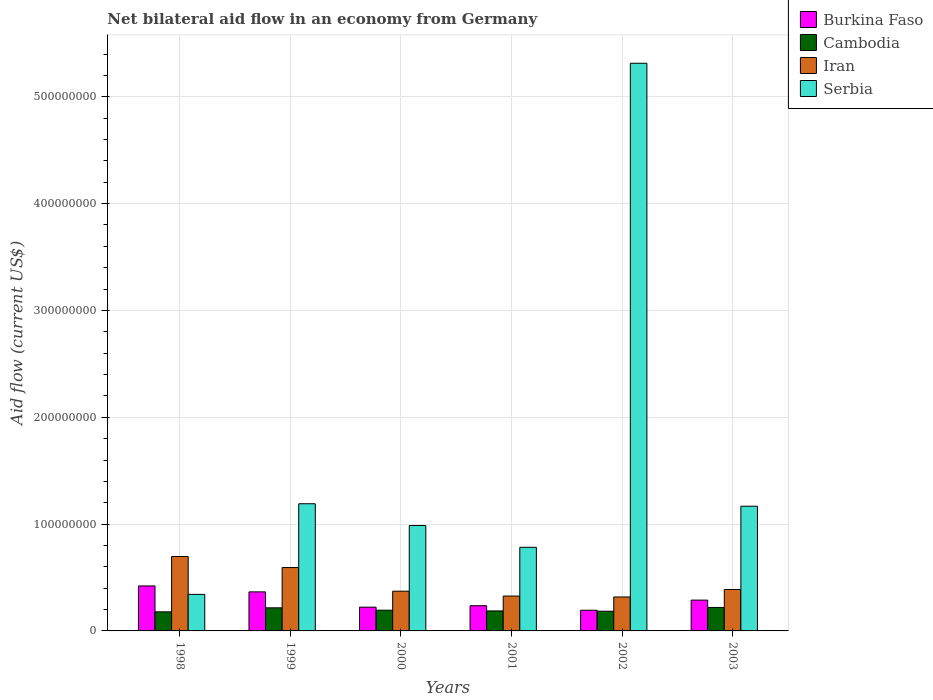Are the number of bars on each tick of the X-axis equal?
Make the answer very short. Yes. How many bars are there on the 2nd tick from the right?
Offer a terse response. 4. What is the label of the 5th group of bars from the left?
Ensure brevity in your answer.  2002. In how many cases, is the number of bars for a given year not equal to the number of legend labels?
Provide a succinct answer. 0. What is the net bilateral aid flow in Iran in 2000?
Offer a very short reply. 3.72e+07. Across all years, what is the maximum net bilateral aid flow in Serbia?
Offer a terse response. 5.31e+08. Across all years, what is the minimum net bilateral aid flow in Serbia?
Provide a succinct answer. 3.42e+07. In which year was the net bilateral aid flow in Burkina Faso maximum?
Keep it short and to the point. 1998. In which year was the net bilateral aid flow in Iran minimum?
Your answer should be very brief. 2002. What is the total net bilateral aid flow in Cambodia in the graph?
Offer a very short reply. 1.18e+08. What is the difference between the net bilateral aid flow in Burkina Faso in 1998 and that in 1999?
Provide a short and direct response. 5.57e+06. What is the difference between the net bilateral aid flow in Serbia in 2000 and the net bilateral aid flow in Cambodia in 1998?
Keep it short and to the point. 8.08e+07. What is the average net bilateral aid flow in Burkina Faso per year?
Give a very brief answer. 2.88e+07. In the year 1999, what is the difference between the net bilateral aid flow in Serbia and net bilateral aid flow in Burkina Faso?
Your answer should be very brief. 8.25e+07. What is the ratio of the net bilateral aid flow in Cambodia in 1998 to that in 2002?
Give a very brief answer. 0.97. Is the difference between the net bilateral aid flow in Serbia in 1999 and 2001 greater than the difference between the net bilateral aid flow in Burkina Faso in 1999 and 2001?
Ensure brevity in your answer.  Yes. What is the difference between the highest and the second highest net bilateral aid flow in Burkina Faso?
Ensure brevity in your answer.  5.57e+06. What is the difference between the highest and the lowest net bilateral aid flow in Burkina Faso?
Keep it short and to the point. 2.28e+07. Is it the case that in every year, the sum of the net bilateral aid flow in Burkina Faso and net bilateral aid flow in Cambodia is greater than the sum of net bilateral aid flow in Serbia and net bilateral aid flow in Iran?
Ensure brevity in your answer.  No. What does the 4th bar from the left in 2001 represents?
Ensure brevity in your answer.  Serbia. What does the 3rd bar from the right in 1998 represents?
Give a very brief answer. Cambodia. Is it the case that in every year, the sum of the net bilateral aid flow in Cambodia and net bilateral aid flow in Serbia is greater than the net bilateral aid flow in Iran?
Your response must be concise. No. How many bars are there?
Give a very brief answer. 24. Are all the bars in the graph horizontal?
Provide a succinct answer. No. How many years are there in the graph?
Offer a terse response. 6. Does the graph contain grids?
Keep it short and to the point. Yes. Where does the legend appear in the graph?
Ensure brevity in your answer.  Top right. What is the title of the graph?
Ensure brevity in your answer.  Net bilateral aid flow in an economy from Germany. Does "St. Martin (French part)" appear as one of the legend labels in the graph?
Your answer should be very brief. No. What is the label or title of the X-axis?
Your answer should be very brief. Years. What is the label or title of the Y-axis?
Give a very brief answer. Aid flow (current US$). What is the Aid flow (current US$) of Burkina Faso in 1998?
Provide a succinct answer. 4.21e+07. What is the Aid flow (current US$) of Cambodia in 1998?
Keep it short and to the point. 1.78e+07. What is the Aid flow (current US$) in Iran in 1998?
Offer a very short reply. 6.97e+07. What is the Aid flow (current US$) in Serbia in 1998?
Provide a short and direct response. 3.42e+07. What is the Aid flow (current US$) of Burkina Faso in 1999?
Provide a short and direct response. 3.65e+07. What is the Aid flow (current US$) in Cambodia in 1999?
Provide a short and direct response. 2.16e+07. What is the Aid flow (current US$) of Iran in 1999?
Keep it short and to the point. 5.93e+07. What is the Aid flow (current US$) of Serbia in 1999?
Your response must be concise. 1.19e+08. What is the Aid flow (current US$) of Burkina Faso in 2000?
Ensure brevity in your answer.  2.22e+07. What is the Aid flow (current US$) in Cambodia in 2000?
Your answer should be compact. 1.94e+07. What is the Aid flow (current US$) in Iran in 2000?
Give a very brief answer. 3.72e+07. What is the Aid flow (current US$) in Serbia in 2000?
Make the answer very short. 9.86e+07. What is the Aid flow (current US$) in Burkina Faso in 2001?
Make the answer very short. 2.36e+07. What is the Aid flow (current US$) in Cambodia in 2001?
Keep it short and to the point. 1.87e+07. What is the Aid flow (current US$) of Iran in 2001?
Keep it short and to the point. 3.26e+07. What is the Aid flow (current US$) in Serbia in 2001?
Offer a very short reply. 7.83e+07. What is the Aid flow (current US$) of Burkina Faso in 2002?
Give a very brief answer. 1.94e+07. What is the Aid flow (current US$) in Cambodia in 2002?
Your answer should be very brief. 1.84e+07. What is the Aid flow (current US$) in Iran in 2002?
Provide a short and direct response. 3.18e+07. What is the Aid flow (current US$) in Serbia in 2002?
Keep it short and to the point. 5.31e+08. What is the Aid flow (current US$) of Burkina Faso in 2003?
Your answer should be compact. 2.88e+07. What is the Aid flow (current US$) of Cambodia in 2003?
Offer a very short reply. 2.20e+07. What is the Aid flow (current US$) in Iran in 2003?
Offer a terse response. 3.88e+07. What is the Aid flow (current US$) of Serbia in 2003?
Your answer should be very brief. 1.17e+08. Across all years, what is the maximum Aid flow (current US$) of Burkina Faso?
Ensure brevity in your answer.  4.21e+07. Across all years, what is the maximum Aid flow (current US$) in Cambodia?
Your answer should be compact. 2.20e+07. Across all years, what is the maximum Aid flow (current US$) of Iran?
Provide a succinct answer. 6.97e+07. Across all years, what is the maximum Aid flow (current US$) in Serbia?
Your answer should be very brief. 5.31e+08. Across all years, what is the minimum Aid flow (current US$) of Burkina Faso?
Give a very brief answer. 1.94e+07. Across all years, what is the minimum Aid flow (current US$) in Cambodia?
Offer a very short reply. 1.78e+07. Across all years, what is the minimum Aid flow (current US$) in Iran?
Offer a very short reply. 3.18e+07. Across all years, what is the minimum Aid flow (current US$) in Serbia?
Give a very brief answer. 3.42e+07. What is the total Aid flow (current US$) in Burkina Faso in the graph?
Make the answer very short. 1.73e+08. What is the total Aid flow (current US$) of Cambodia in the graph?
Offer a terse response. 1.18e+08. What is the total Aid flow (current US$) in Iran in the graph?
Your response must be concise. 2.69e+08. What is the total Aid flow (current US$) in Serbia in the graph?
Provide a short and direct response. 9.78e+08. What is the difference between the Aid flow (current US$) of Burkina Faso in 1998 and that in 1999?
Your answer should be compact. 5.57e+06. What is the difference between the Aid flow (current US$) of Cambodia in 1998 and that in 1999?
Offer a terse response. -3.77e+06. What is the difference between the Aid flow (current US$) in Iran in 1998 and that in 1999?
Provide a short and direct response. 1.03e+07. What is the difference between the Aid flow (current US$) of Serbia in 1998 and that in 1999?
Offer a terse response. -8.48e+07. What is the difference between the Aid flow (current US$) in Burkina Faso in 1998 and that in 2000?
Provide a short and direct response. 1.99e+07. What is the difference between the Aid flow (current US$) in Cambodia in 1998 and that in 2000?
Offer a terse response. -1.55e+06. What is the difference between the Aid flow (current US$) of Iran in 1998 and that in 2000?
Keep it short and to the point. 3.25e+07. What is the difference between the Aid flow (current US$) of Serbia in 1998 and that in 2000?
Offer a terse response. -6.44e+07. What is the difference between the Aid flow (current US$) of Burkina Faso in 1998 and that in 2001?
Make the answer very short. 1.85e+07. What is the difference between the Aid flow (current US$) of Cambodia in 1998 and that in 2001?
Ensure brevity in your answer.  -8.70e+05. What is the difference between the Aid flow (current US$) of Iran in 1998 and that in 2001?
Your response must be concise. 3.70e+07. What is the difference between the Aid flow (current US$) of Serbia in 1998 and that in 2001?
Keep it short and to the point. -4.41e+07. What is the difference between the Aid flow (current US$) in Burkina Faso in 1998 and that in 2002?
Your answer should be compact. 2.28e+07. What is the difference between the Aid flow (current US$) in Cambodia in 1998 and that in 2002?
Give a very brief answer. -5.90e+05. What is the difference between the Aid flow (current US$) in Iran in 1998 and that in 2002?
Offer a terse response. 3.79e+07. What is the difference between the Aid flow (current US$) of Serbia in 1998 and that in 2002?
Your answer should be compact. -4.97e+08. What is the difference between the Aid flow (current US$) of Burkina Faso in 1998 and that in 2003?
Provide a succinct answer. 1.33e+07. What is the difference between the Aid flow (current US$) in Cambodia in 1998 and that in 2003?
Your answer should be compact. -4.13e+06. What is the difference between the Aid flow (current US$) of Iran in 1998 and that in 2003?
Your answer should be compact. 3.09e+07. What is the difference between the Aid flow (current US$) in Serbia in 1998 and that in 2003?
Provide a succinct answer. -8.26e+07. What is the difference between the Aid flow (current US$) in Burkina Faso in 1999 and that in 2000?
Offer a terse response. 1.43e+07. What is the difference between the Aid flow (current US$) in Cambodia in 1999 and that in 2000?
Your answer should be compact. 2.22e+06. What is the difference between the Aid flow (current US$) in Iran in 1999 and that in 2000?
Make the answer very short. 2.21e+07. What is the difference between the Aid flow (current US$) of Serbia in 1999 and that in 2000?
Keep it short and to the point. 2.04e+07. What is the difference between the Aid flow (current US$) in Burkina Faso in 1999 and that in 2001?
Provide a succinct answer. 1.29e+07. What is the difference between the Aid flow (current US$) in Cambodia in 1999 and that in 2001?
Offer a very short reply. 2.90e+06. What is the difference between the Aid flow (current US$) in Iran in 1999 and that in 2001?
Offer a terse response. 2.67e+07. What is the difference between the Aid flow (current US$) in Serbia in 1999 and that in 2001?
Provide a short and direct response. 4.08e+07. What is the difference between the Aid flow (current US$) in Burkina Faso in 1999 and that in 2002?
Your answer should be compact. 1.72e+07. What is the difference between the Aid flow (current US$) of Cambodia in 1999 and that in 2002?
Your answer should be compact. 3.18e+06. What is the difference between the Aid flow (current US$) of Iran in 1999 and that in 2002?
Your answer should be compact. 2.76e+07. What is the difference between the Aid flow (current US$) in Serbia in 1999 and that in 2002?
Ensure brevity in your answer.  -4.12e+08. What is the difference between the Aid flow (current US$) in Burkina Faso in 1999 and that in 2003?
Offer a terse response. 7.71e+06. What is the difference between the Aid flow (current US$) of Cambodia in 1999 and that in 2003?
Provide a short and direct response. -3.60e+05. What is the difference between the Aid flow (current US$) in Iran in 1999 and that in 2003?
Make the answer very short. 2.06e+07. What is the difference between the Aid flow (current US$) of Serbia in 1999 and that in 2003?
Offer a very short reply. 2.30e+06. What is the difference between the Aid flow (current US$) in Burkina Faso in 2000 and that in 2001?
Your answer should be compact. -1.36e+06. What is the difference between the Aid flow (current US$) of Cambodia in 2000 and that in 2001?
Keep it short and to the point. 6.80e+05. What is the difference between the Aid flow (current US$) of Iran in 2000 and that in 2001?
Your response must be concise. 4.55e+06. What is the difference between the Aid flow (current US$) in Serbia in 2000 and that in 2001?
Give a very brief answer. 2.04e+07. What is the difference between the Aid flow (current US$) of Burkina Faso in 2000 and that in 2002?
Offer a terse response. 2.89e+06. What is the difference between the Aid flow (current US$) of Cambodia in 2000 and that in 2002?
Provide a short and direct response. 9.60e+05. What is the difference between the Aid flow (current US$) in Iran in 2000 and that in 2002?
Ensure brevity in your answer.  5.41e+06. What is the difference between the Aid flow (current US$) in Serbia in 2000 and that in 2002?
Give a very brief answer. -4.33e+08. What is the difference between the Aid flow (current US$) of Burkina Faso in 2000 and that in 2003?
Your response must be concise. -6.59e+06. What is the difference between the Aid flow (current US$) in Cambodia in 2000 and that in 2003?
Offer a very short reply. -2.58e+06. What is the difference between the Aid flow (current US$) in Iran in 2000 and that in 2003?
Your answer should be compact. -1.58e+06. What is the difference between the Aid flow (current US$) of Serbia in 2000 and that in 2003?
Make the answer very short. -1.81e+07. What is the difference between the Aid flow (current US$) of Burkina Faso in 2001 and that in 2002?
Ensure brevity in your answer.  4.25e+06. What is the difference between the Aid flow (current US$) of Iran in 2001 and that in 2002?
Offer a very short reply. 8.60e+05. What is the difference between the Aid flow (current US$) in Serbia in 2001 and that in 2002?
Offer a very short reply. -4.53e+08. What is the difference between the Aid flow (current US$) of Burkina Faso in 2001 and that in 2003?
Ensure brevity in your answer.  -5.23e+06. What is the difference between the Aid flow (current US$) in Cambodia in 2001 and that in 2003?
Keep it short and to the point. -3.26e+06. What is the difference between the Aid flow (current US$) in Iran in 2001 and that in 2003?
Make the answer very short. -6.13e+06. What is the difference between the Aid flow (current US$) of Serbia in 2001 and that in 2003?
Make the answer very short. -3.85e+07. What is the difference between the Aid flow (current US$) in Burkina Faso in 2002 and that in 2003?
Your response must be concise. -9.48e+06. What is the difference between the Aid flow (current US$) of Cambodia in 2002 and that in 2003?
Ensure brevity in your answer.  -3.54e+06. What is the difference between the Aid flow (current US$) of Iran in 2002 and that in 2003?
Ensure brevity in your answer.  -6.99e+06. What is the difference between the Aid flow (current US$) in Serbia in 2002 and that in 2003?
Your answer should be very brief. 4.15e+08. What is the difference between the Aid flow (current US$) in Burkina Faso in 1998 and the Aid flow (current US$) in Cambodia in 1999?
Offer a very short reply. 2.05e+07. What is the difference between the Aid flow (current US$) of Burkina Faso in 1998 and the Aid flow (current US$) of Iran in 1999?
Your response must be concise. -1.72e+07. What is the difference between the Aid flow (current US$) in Burkina Faso in 1998 and the Aid flow (current US$) in Serbia in 1999?
Provide a short and direct response. -7.69e+07. What is the difference between the Aid flow (current US$) in Cambodia in 1998 and the Aid flow (current US$) in Iran in 1999?
Make the answer very short. -4.15e+07. What is the difference between the Aid flow (current US$) in Cambodia in 1998 and the Aid flow (current US$) in Serbia in 1999?
Provide a succinct answer. -1.01e+08. What is the difference between the Aid flow (current US$) of Iran in 1998 and the Aid flow (current US$) of Serbia in 1999?
Your response must be concise. -4.94e+07. What is the difference between the Aid flow (current US$) of Burkina Faso in 1998 and the Aid flow (current US$) of Cambodia in 2000?
Ensure brevity in your answer.  2.27e+07. What is the difference between the Aid flow (current US$) in Burkina Faso in 1998 and the Aid flow (current US$) in Iran in 2000?
Offer a very short reply. 4.92e+06. What is the difference between the Aid flow (current US$) in Burkina Faso in 1998 and the Aid flow (current US$) in Serbia in 2000?
Your answer should be compact. -5.65e+07. What is the difference between the Aid flow (current US$) of Cambodia in 1998 and the Aid flow (current US$) of Iran in 2000?
Give a very brief answer. -1.93e+07. What is the difference between the Aid flow (current US$) in Cambodia in 1998 and the Aid flow (current US$) in Serbia in 2000?
Offer a terse response. -8.08e+07. What is the difference between the Aid flow (current US$) of Iran in 1998 and the Aid flow (current US$) of Serbia in 2000?
Your answer should be very brief. -2.90e+07. What is the difference between the Aid flow (current US$) of Burkina Faso in 1998 and the Aid flow (current US$) of Cambodia in 2001?
Keep it short and to the point. 2.34e+07. What is the difference between the Aid flow (current US$) of Burkina Faso in 1998 and the Aid flow (current US$) of Iran in 2001?
Give a very brief answer. 9.47e+06. What is the difference between the Aid flow (current US$) of Burkina Faso in 1998 and the Aid flow (current US$) of Serbia in 2001?
Your response must be concise. -3.62e+07. What is the difference between the Aid flow (current US$) of Cambodia in 1998 and the Aid flow (current US$) of Iran in 2001?
Offer a very short reply. -1.48e+07. What is the difference between the Aid flow (current US$) of Cambodia in 1998 and the Aid flow (current US$) of Serbia in 2001?
Offer a very short reply. -6.04e+07. What is the difference between the Aid flow (current US$) in Iran in 1998 and the Aid flow (current US$) in Serbia in 2001?
Give a very brief answer. -8.61e+06. What is the difference between the Aid flow (current US$) of Burkina Faso in 1998 and the Aid flow (current US$) of Cambodia in 2002?
Your answer should be very brief. 2.37e+07. What is the difference between the Aid flow (current US$) in Burkina Faso in 1998 and the Aid flow (current US$) in Iran in 2002?
Keep it short and to the point. 1.03e+07. What is the difference between the Aid flow (current US$) in Burkina Faso in 1998 and the Aid flow (current US$) in Serbia in 2002?
Keep it short and to the point. -4.89e+08. What is the difference between the Aid flow (current US$) in Cambodia in 1998 and the Aid flow (current US$) in Iran in 2002?
Provide a short and direct response. -1.39e+07. What is the difference between the Aid flow (current US$) of Cambodia in 1998 and the Aid flow (current US$) of Serbia in 2002?
Offer a terse response. -5.14e+08. What is the difference between the Aid flow (current US$) of Iran in 1998 and the Aid flow (current US$) of Serbia in 2002?
Offer a terse response. -4.62e+08. What is the difference between the Aid flow (current US$) in Burkina Faso in 1998 and the Aid flow (current US$) in Cambodia in 2003?
Your answer should be very brief. 2.01e+07. What is the difference between the Aid flow (current US$) in Burkina Faso in 1998 and the Aid flow (current US$) in Iran in 2003?
Provide a short and direct response. 3.34e+06. What is the difference between the Aid flow (current US$) in Burkina Faso in 1998 and the Aid flow (current US$) in Serbia in 2003?
Keep it short and to the point. -7.46e+07. What is the difference between the Aid flow (current US$) of Cambodia in 1998 and the Aid flow (current US$) of Iran in 2003?
Ensure brevity in your answer.  -2.09e+07. What is the difference between the Aid flow (current US$) of Cambodia in 1998 and the Aid flow (current US$) of Serbia in 2003?
Offer a very short reply. -9.89e+07. What is the difference between the Aid flow (current US$) in Iran in 1998 and the Aid flow (current US$) in Serbia in 2003?
Give a very brief answer. -4.71e+07. What is the difference between the Aid flow (current US$) in Burkina Faso in 1999 and the Aid flow (current US$) in Cambodia in 2000?
Offer a very short reply. 1.71e+07. What is the difference between the Aid flow (current US$) of Burkina Faso in 1999 and the Aid flow (current US$) of Iran in 2000?
Your answer should be compact. -6.50e+05. What is the difference between the Aid flow (current US$) in Burkina Faso in 1999 and the Aid flow (current US$) in Serbia in 2000?
Offer a very short reply. -6.21e+07. What is the difference between the Aid flow (current US$) in Cambodia in 1999 and the Aid flow (current US$) in Iran in 2000?
Provide a succinct answer. -1.56e+07. What is the difference between the Aid flow (current US$) of Cambodia in 1999 and the Aid flow (current US$) of Serbia in 2000?
Provide a succinct answer. -7.70e+07. What is the difference between the Aid flow (current US$) of Iran in 1999 and the Aid flow (current US$) of Serbia in 2000?
Keep it short and to the point. -3.93e+07. What is the difference between the Aid flow (current US$) in Burkina Faso in 1999 and the Aid flow (current US$) in Cambodia in 2001?
Your response must be concise. 1.78e+07. What is the difference between the Aid flow (current US$) of Burkina Faso in 1999 and the Aid flow (current US$) of Iran in 2001?
Make the answer very short. 3.90e+06. What is the difference between the Aid flow (current US$) of Burkina Faso in 1999 and the Aid flow (current US$) of Serbia in 2001?
Ensure brevity in your answer.  -4.17e+07. What is the difference between the Aid flow (current US$) in Cambodia in 1999 and the Aid flow (current US$) in Iran in 2001?
Offer a terse response. -1.10e+07. What is the difference between the Aid flow (current US$) in Cambodia in 1999 and the Aid flow (current US$) in Serbia in 2001?
Offer a very short reply. -5.67e+07. What is the difference between the Aid flow (current US$) of Iran in 1999 and the Aid flow (current US$) of Serbia in 2001?
Offer a very short reply. -1.90e+07. What is the difference between the Aid flow (current US$) in Burkina Faso in 1999 and the Aid flow (current US$) in Cambodia in 2002?
Give a very brief answer. 1.81e+07. What is the difference between the Aid flow (current US$) of Burkina Faso in 1999 and the Aid flow (current US$) of Iran in 2002?
Provide a succinct answer. 4.76e+06. What is the difference between the Aid flow (current US$) of Burkina Faso in 1999 and the Aid flow (current US$) of Serbia in 2002?
Keep it short and to the point. -4.95e+08. What is the difference between the Aid flow (current US$) of Cambodia in 1999 and the Aid flow (current US$) of Iran in 2002?
Offer a very short reply. -1.02e+07. What is the difference between the Aid flow (current US$) in Cambodia in 1999 and the Aid flow (current US$) in Serbia in 2002?
Keep it short and to the point. -5.10e+08. What is the difference between the Aid flow (current US$) in Iran in 1999 and the Aid flow (current US$) in Serbia in 2002?
Your answer should be very brief. -4.72e+08. What is the difference between the Aid flow (current US$) in Burkina Faso in 1999 and the Aid flow (current US$) in Cambodia in 2003?
Offer a terse response. 1.46e+07. What is the difference between the Aid flow (current US$) of Burkina Faso in 1999 and the Aid flow (current US$) of Iran in 2003?
Offer a very short reply. -2.23e+06. What is the difference between the Aid flow (current US$) in Burkina Faso in 1999 and the Aid flow (current US$) in Serbia in 2003?
Provide a succinct answer. -8.02e+07. What is the difference between the Aid flow (current US$) of Cambodia in 1999 and the Aid flow (current US$) of Iran in 2003?
Provide a succinct answer. -1.72e+07. What is the difference between the Aid flow (current US$) of Cambodia in 1999 and the Aid flow (current US$) of Serbia in 2003?
Keep it short and to the point. -9.51e+07. What is the difference between the Aid flow (current US$) of Iran in 1999 and the Aid flow (current US$) of Serbia in 2003?
Your answer should be very brief. -5.74e+07. What is the difference between the Aid flow (current US$) of Burkina Faso in 2000 and the Aid flow (current US$) of Cambodia in 2001?
Offer a very short reply. 3.52e+06. What is the difference between the Aid flow (current US$) of Burkina Faso in 2000 and the Aid flow (current US$) of Iran in 2001?
Keep it short and to the point. -1.04e+07. What is the difference between the Aid flow (current US$) of Burkina Faso in 2000 and the Aid flow (current US$) of Serbia in 2001?
Keep it short and to the point. -5.60e+07. What is the difference between the Aid flow (current US$) of Cambodia in 2000 and the Aid flow (current US$) of Iran in 2001?
Provide a succinct answer. -1.32e+07. What is the difference between the Aid flow (current US$) in Cambodia in 2000 and the Aid flow (current US$) in Serbia in 2001?
Provide a succinct answer. -5.89e+07. What is the difference between the Aid flow (current US$) in Iran in 2000 and the Aid flow (current US$) in Serbia in 2001?
Keep it short and to the point. -4.11e+07. What is the difference between the Aid flow (current US$) of Burkina Faso in 2000 and the Aid flow (current US$) of Cambodia in 2002?
Provide a succinct answer. 3.80e+06. What is the difference between the Aid flow (current US$) in Burkina Faso in 2000 and the Aid flow (current US$) in Iran in 2002?
Make the answer very short. -9.54e+06. What is the difference between the Aid flow (current US$) in Burkina Faso in 2000 and the Aid flow (current US$) in Serbia in 2002?
Your answer should be compact. -5.09e+08. What is the difference between the Aid flow (current US$) in Cambodia in 2000 and the Aid flow (current US$) in Iran in 2002?
Keep it short and to the point. -1.24e+07. What is the difference between the Aid flow (current US$) of Cambodia in 2000 and the Aid flow (current US$) of Serbia in 2002?
Provide a short and direct response. -5.12e+08. What is the difference between the Aid flow (current US$) in Iran in 2000 and the Aid flow (current US$) in Serbia in 2002?
Provide a short and direct response. -4.94e+08. What is the difference between the Aid flow (current US$) of Burkina Faso in 2000 and the Aid flow (current US$) of Cambodia in 2003?
Your answer should be compact. 2.60e+05. What is the difference between the Aid flow (current US$) of Burkina Faso in 2000 and the Aid flow (current US$) of Iran in 2003?
Ensure brevity in your answer.  -1.65e+07. What is the difference between the Aid flow (current US$) of Burkina Faso in 2000 and the Aid flow (current US$) of Serbia in 2003?
Offer a very short reply. -9.45e+07. What is the difference between the Aid flow (current US$) in Cambodia in 2000 and the Aid flow (current US$) in Iran in 2003?
Your response must be concise. -1.94e+07. What is the difference between the Aid flow (current US$) of Cambodia in 2000 and the Aid flow (current US$) of Serbia in 2003?
Provide a short and direct response. -9.74e+07. What is the difference between the Aid flow (current US$) in Iran in 2000 and the Aid flow (current US$) in Serbia in 2003?
Make the answer very short. -7.96e+07. What is the difference between the Aid flow (current US$) in Burkina Faso in 2001 and the Aid flow (current US$) in Cambodia in 2002?
Keep it short and to the point. 5.16e+06. What is the difference between the Aid flow (current US$) in Burkina Faso in 2001 and the Aid flow (current US$) in Iran in 2002?
Offer a terse response. -8.18e+06. What is the difference between the Aid flow (current US$) of Burkina Faso in 2001 and the Aid flow (current US$) of Serbia in 2002?
Ensure brevity in your answer.  -5.08e+08. What is the difference between the Aid flow (current US$) in Cambodia in 2001 and the Aid flow (current US$) in Iran in 2002?
Your response must be concise. -1.31e+07. What is the difference between the Aid flow (current US$) of Cambodia in 2001 and the Aid flow (current US$) of Serbia in 2002?
Provide a short and direct response. -5.13e+08. What is the difference between the Aid flow (current US$) in Iran in 2001 and the Aid flow (current US$) in Serbia in 2002?
Offer a terse response. -4.99e+08. What is the difference between the Aid flow (current US$) in Burkina Faso in 2001 and the Aid flow (current US$) in Cambodia in 2003?
Your answer should be compact. 1.62e+06. What is the difference between the Aid flow (current US$) in Burkina Faso in 2001 and the Aid flow (current US$) in Iran in 2003?
Offer a terse response. -1.52e+07. What is the difference between the Aid flow (current US$) of Burkina Faso in 2001 and the Aid flow (current US$) of Serbia in 2003?
Your response must be concise. -9.32e+07. What is the difference between the Aid flow (current US$) in Cambodia in 2001 and the Aid flow (current US$) in Iran in 2003?
Your response must be concise. -2.00e+07. What is the difference between the Aid flow (current US$) of Cambodia in 2001 and the Aid flow (current US$) of Serbia in 2003?
Offer a very short reply. -9.80e+07. What is the difference between the Aid flow (current US$) in Iran in 2001 and the Aid flow (current US$) in Serbia in 2003?
Give a very brief answer. -8.41e+07. What is the difference between the Aid flow (current US$) of Burkina Faso in 2002 and the Aid flow (current US$) of Cambodia in 2003?
Give a very brief answer. -2.63e+06. What is the difference between the Aid flow (current US$) of Burkina Faso in 2002 and the Aid flow (current US$) of Iran in 2003?
Keep it short and to the point. -1.94e+07. What is the difference between the Aid flow (current US$) of Burkina Faso in 2002 and the Aid flow (current US$) of Serbia in 2003?
Ensure brevity in your answer.  -9.74e+07. What is the difference between the Aid flow (current US$) in Cambodia in 2002 and the Aid flow (current US$) in Iran in 2003?
Your answer should be compact. -2.03e+07. What is the difference between the Aid flow (current US$) in Cambodia in 2002 and the Aid flow (current US$) in Serbia in 2003?
Offer a very short reply. -9.83e+07. What is the difference between the Aid flow (current US$) of Iran in 2002 and the Aid flow (current US$) of Serbia in 2003?
Make the answer very short. -8.50e+07. What is the average Aid flow (current US$) of Burkina Faso per year?
Keep it short and to the point. 2.88e+07. What is the average Aid flow (current US$) in Cambodia per year?
Your answer should be compact. 1.97e+07. What is the average Aid flow (current US$) of Iran per year?
Keep it short and to the point. 4.49e+07. What is the average Aid flow (current US$) of Serbia per year?
Keep it short and to the point. 1.63e+08. In the year 1998, what is the difference between the Aid flow (current US$) in Burkina Faso and Aid flow (current US$) in Cambodia?
Your answer should be compact. 2.43e+07. In the year 1998, what is the difference between the Aid flow (current US$) of Burkina Faso and Aid flow (current US$) of Iran?
Your answer should be compact. -2.76e+07. In the year 1998, what is the difference between the Aid flow (current US$) in Burkina Faso and Aid flow (current US$) in Serbia?
Keep it short and to the point. 7.91e+06. In the year 1998, what is the difference between the Aid flow (current US$) of Cambodia and Aid flow (current US$) of Iran?
Give a very brief answer. -5.18e+07. In the year 1998, what is the difference between the Aid flow (current US$) in Cambodia and Aid flow (current US$) in Serbia?
Your answer should be very brief. -1.64e+07. In the year 1998, what is the difference between the Aid flow (current US$) in Iran and Aid flow (current US$) in Serbia?
Your response must be concise. 3.55e+07. In the year 1999, what is the difference between the Aid flow (current US$) in Burkina Faso and Aid flow (current US$) in Cambodia?
Offer a terse response. 1.49e+07. In the year 1999, what is the difference between the Aid flow (current US$) of Burkina Faso and Aid flow (current US$) of Iran?
Provide a short and direct response. -2.28e+07. In the year 1999, what is the difference between the Aid flow (current US$) in Burkina Faso and Aid flow (current US$) in Serbia?
Your response must be concise. -8.25e+07. In the year 1999, what is the difference between the Aid flow (current US$) of Cambodia and Aid flow (current US$) of Iran?
Make the answer very short. -3.77e+07. In the year 1999, what is the difference between the Aid flow (current US$) in Cambodia and Aid flow (current US$) in Serbia?
Give a very brief answer. -9.74e+07. In the year 1999, what is the difference between the Aid flow (current US$) in Iran and Aid flow (current US$) in Serbia?
Your response must be concise. -5.97e+07. In the year 2000, what is the difference between the Aid flow (current US$) in Burkina Faso and Aid flow (current US$) in Cambodia?
Make the answer very short. 2.84e+06. In the year 2000, what is the difference between the Aid flow (current US$) in Burkina Faso and Aid flow (current US$) in Iran?
Your answer should be compact. -1.50e+07. In the year 2000, what is the difference between the Aid flow (current US$) in Burkina Faso and Aid flow (current US$) in Serbia?
Offer a very short reply. -7.64e+07. In the year 2000, what is the difference between the Aid flow (current US$) of Cambodia and Aid flow (current US$) of Iran?
Your answer should be compact. -1.78e+07. In the year 2000, what is the difference between the Aid flow (current US$) of Cambodia and Aid flow (current US$) of Serbia?
Offer a terse response. -7.92e+07. In the year 2000, what is the difference between the Aid flow (current US$) of Iran and Aid flow (current US$) of Serbia?
Provide a succinct answer. -6.15e+07. In the year 2001, what is the difference between the Aid flow (current US$) of Burkina Faso and Aid flow (current US$) of Cambodia?
Offer a terse response. 4.88e+06. In the year 2001, what is the difference between the Aid flow (current US$) in Burkina Faso and Aid flow (current US$) in Iran?
Make the answer very short. -9.04e+06. In the year 2001, what is the difference between the Aid flow (current US$) of Burkina Faso and Aid flow (current US$) of Serbia?
Give a very brief answer. -5.47e+07. In the year 2001, what is the difference between the Aid flow (current US$) in Cambodia and Aid flow (current US$) in Iran?
Provide a short and direct response. -1.39e+07. In the year 2001, what is the difference between the Aid flow (current US$) in Cambodia and Aid flow (current US$) in Serbia?
Your answer should be very brief. -5.96e+07. In the year 2001, what is the difference between the Aid flow (current US$) of Iran and Aid flow (current US$) of Serbia?
Provide a short and direct response. -4.56e+07. In the year 2002, what is the difference between the Aid flow (current US$) of Burkina Faso and Aid flow (current US$) of Cambodia?
Offer a terse response. 9.10e+05. In the year 2002, what is the difference between the Aid flow (current US$) in Burkina Faso and Aid flow (current US$) in Iran?
Provide a short and direct response. -1.24e+07. In the year 2002, what is the difference between the Aid flow (current US$) of Burkina Faso and Aid flow (current US$) of Serbia?
Offer a very short reply. -5.12e+08. In the year 2002, what is the difference between the Aid flow (current US$) of Cambodia and Aid flow (current US$) of Iran?
Your response must be concise. -1.33e+07. In the year 2002, what is the difference between the Aid flow (current US$) in Cambodia and Aid flow (current US$) in Serbia?
Make the answer very short. -5.13e+08. In the year 2002, what is the difference between the Aid flow (current US$) in Iran and Aid flow (current US$) in Serbia?
Provide a succinct answer. -5.00e+08. In the year 2003, what is the difference between the Aid flow (current US$) of Burkina Faso and Aid flow (current US$) of Cambodia?
Your answer should be very brief. 6.85e+06. In the year 2003, what is the difference between the Aid flow (current US$) of Burkina Faso and Aid flow (current US$) of Iran?
Ensure brevity in your answer.  -9.94e+06. In the year 2003, what is the difference between the Aid flow (current US$) in Burkina Faso and Aid flow (current US$) in Serbia?
Offer a terse response. -8.79e+07. In the year 2003, what is the difference between the Aid flow (current US$) in Cambodia and Aid flow (current US$) in Iran?
Offer a very short reply. -1.68e+07. In the year 2003, what is the difference between the Aid flow (current US$) of Cambodia and Aid flow (current US$) of Serbia?
Your response must be concise. -9.48e+07. In the year 2003, what is the difference between the Aid flow (current US$) of Iran and Aid flow (current US$) of Serbia?
Give a very brief answer. -7.80e+07. What is the ratio of the Aid flow (current US$) of Burkina Faso in 1998 to that in 1999?
Make the answer very short. 1.15. What is the ratio of the Aid flow (current US$) of Cambodia in 1998 to that in 1999?
Your answer should be very brief. 0.83. What is the ratio of the Aid flow (current US$) of Iran in 1998 to that in 1999?
Offer a very short reply. 1.17. What is the ratio of the Aid flow (current US$) in Serbia in 1998 to that in 1999?
Your answer should be compact. 0.29. What is the ratio of the Aid flow (current US$) of Burkina Faso in 1998 to that in 2000?
Provide a succinct answer. 1.89. What is the ratio of the Aid flow (current US$) of Cambodia in 1998 to that in 2000?
Make the answer very short. 0.92. What is the ratio of the Aid flow (current US$) of Iran in 1998 to that in 2000?
Your answer should be compact. 1.87. What is the ratio of the Aid flow (current US$) of Serbia in 1998 to that in 2000?
Provide a succinct answer. 0.35. What is the ratio of the Aid flow (current US$) of Burkina Faso in 1998 to that in 2001?
Offer a terse response. 1.78. What is the ratio of the Aid flow (current US$) in Cambodia in 1998 to that in 2001?
Provide a short and direct response. 0.95. What is the ratio of the Aid flow (current US$) of Iran in 1998 to that in 2001?
Keep it short and to the point. 2.13. What is the ratio of the Aid flow (current US$) in Serbia in 1998 to that in 2001?
Ensure brevity in your answer.  0.44. What is the ratio of the Aid flow (current US$) in Burkina Faso in 1998 to that in 2002?
Ensure brevity in your answer.  2.18. What is the ratio of the Aid flow (current US$) in Cambodia in 1998 to that in 2002?
Provide a succinct answer. 0.97. What is the ratio of the Aid flow (current US$) of Iran in 1998 to that in 2002?
Ensure brevity in your answer.  2.19. What is the ratio of the Aid flow (current US$) of Serbia in 1998 to that in 2002?
Give a very brief answer. 0.06. What is the ratio of the Aid flow (current US$) in Burkina Faso in 1998 to that in 2003?
Your answer should be compact. 1.46. What is the ratio of the Aid flow (current US$) of Cambodia in 1998 to that in 2003?
Your answer should be very brief. 0.81. What is the ratio of the Aid flow (current US$) in Iran in 1998 to that in 2003?
Offer a terse response. 1.8. What is the ratio of the Aid flow (current US$) of Serbia in 1998 to that in 2003?
Offer a terse response. 0.29. What is the ratio of the Aid flow (current US$) in Burkina Faso in 1999 to that in 2000?
Ensure brevity in your answer.  1.64. What is the ratio of the Aid flow (current US$) in Cambodia in 1999 to that in 2000?
Keep it short and to the point. 1.11. What is the ratio of the Aid flow (current US$) in Iran in 1999 to that in 2000?
Provide a succinct answer. 1.6. What is the ratio of the Aid flow (current US$) of Serbia in 1999 to that in 2000?
Ensure brevity in your answer.  1.21. What is the ratio of the Aid flow (current US$) in Burkina Faso in 1999 to that in 2001?
Offer a very short reply. 1.55. What is the ratio of the Aid flow (current US$) of Cambodia in 1999 to that in 2001?
Your answer should be very brief. 1.15. What is the ratio of the Aid flow (current US$) of Iran in 1999 to that in 2001?
Provide a succinct answer. 1.82. What is the ratio of the Aid flow (current US$) in Serbia in 1999 to that in 2001?
Offer a terse response. 1.52. What is the ratio of the Aid flow (current US$) of Burkina Faso in 1999 to that in 2002?
Provide a succinct answer. 1.89. What is the ratio of the Aid flow (current US$) in Cambodia in 1999 to that in 2002?
Your answer should be compact. 1.17. What is the ratio of the Aid flow (current US$) of Iran in 1999 to that in 2002?
Offer a very short reply. 1.87. What is the ratio of the Aid flow (current US$) of Serbia in 1999 to that in 2002?
Ensure brevity in your answer.  0.22. What is the ratio of the Aid flow (current US$) in Burkina Faso in 1999 to that in 2003?
Provide a short and direct response. 1.27. What is the ratio of the Aid flow (current US$) of Cambodia in 1999 to that in 2003?
Provide a short and direct response. 0.98. What is the ratio of the Aid flow (current US$) in Iran in 1999 to that in 2003?
Offer a terse response. 1.53. What is the ratio of the Aid flow (current US$) of Serbia in 1999 to that in 2003?
Your answer should be very brief. 1.02. What is the ratio of the Aid flow (current US$) in Burkina Faso in 2000 to that in 2001?
Offer a terse response. 0.94. What is the ratio of the Aid flow (current US$) in Cambodia in 2000 to that in 2001?
Your answer should be very brief. 1.04. What is the ratio of the Aid flow (current US$) in Iran in 2000 to that in 2001?
Offer a very short reply. 1.14. What is the ratio of the Aid flow (current US$) of Serbia in 2000 to that in 2001?
Your answer should be very brief. 1.26. What is the ratio of the Aid flow (current US$) of Burkina Faso in 2000 to that in 2002?
Provide a short and direct response. 1.15. What is the ratio of the Aid flow (current US$) of Cambodia in 2000 to that in 2002?
Your answer should be compact. 1.05. What is the ratio of the Aid flow (current US$) in Iran in 2000 to that in 2002?
Make the answer very short. 1.17. What is the ratio of the Aid flow (current US$) in Serbia in 2000 to that in 2002?
Your response must be concise. 0.19. What is the ratio of the Aid flow (current US$) of Burkina Faso in 2000 to that in 2003?
Offer a terse response. 0.77. What is the ratio of the Aid flow (current US$) of Cambodia in 2000 to that in 2003?
Ensure brevity in your answer.  0.88. What is the ratio of the Aid flow (current US$) of Iran in 2000 to that in 2003?
Offer a very short reply. 0.96. What is the ratio of the Aid flow (current US$) of Serbia in 2000 to that in 2003?
Give a very brief answer. 0.84. What is the ratio of the Aid flow (current US$) of Burkina Faso in 2001 to that in 2002?
Provide a short and direct response. 1.22. What is the ratio of the Aid flow (current US$) of Cambodia in 2001 to that in 2002?
Offer a terse response. 1.02. What is the ratio of the Aid flow (current US$) of Iran in 2001 to that in 2002?
Ensure brevity in your answer.  1.03. What is the ratio of the Aid flow (current US$) of Serbia in 2001 to that in 2002?
Make the answer very short. 0.15. What is the ratio of the Aid flow (current US$) of Burkina Faso in 2001 to that in 2003?
Provide a short and direct response. 0.82. What is the ratio of the Aid flow (current US$) of Cambodia in 2001 to that in 2003?
Ensure brevity in your answer.  0.85. What is the ratio of the Aid flow (current US$) of Iran in 2001 to that in 2003?
Your response must be concise. 0.84. What is the ratio of the Aid flow (current US$) of Serbia in 2001 to that in 2003?
Offer a terse response. 0.67. What is the ratio of the Aid flow (current US$) of Burkina Faso in 2002 to that in 2003?
Provide a succinct answer. 0.67. What is the ratio of the Aid flow (current US$) of Cambodia in 2002 to that in 2003?
Make the answer very short. 0.84. What is the ratio of the Aid flow (current US$) of Iran in 2002 to that in 2003?
Offer a terse response. 0.82. What is the ratio of the Aid flow (current US$) in Serbia in 2002 to that in 2003?
Your answer should be very brief. 4.55. What is the difference between the highest and the second highest Aid flow (current US$) in Burkina Faso?
Offer a terse response. 5.57e+06. What is the difference between the highest and the second highest Aid flow (current US$) in Iran?
Ensure brevity in your answer.  1.03e+07. What is the difference between the highest and the second highest Aid flow (current US$) in Serbia?
Offer a very short reply. 4.12e+08. What is the difference between the highest and the lowest Aid flow (current US$) in Burkina Faso?
Keep it short and to the point. 2.28e+07. What is the difference between the highest and the lowest Aid flow (current US$) of Cambodia?
Offer a very short reply. 4.13e+06. What is the difference between the highest and the lowest Aid flow (current US$) in Iran?
Your response must be concise. 3.79e+07. What is the difference between the highest and the lowest Aid flow (current US$) of Serbia?
Provide a short and direct response. 4.97e+08. 